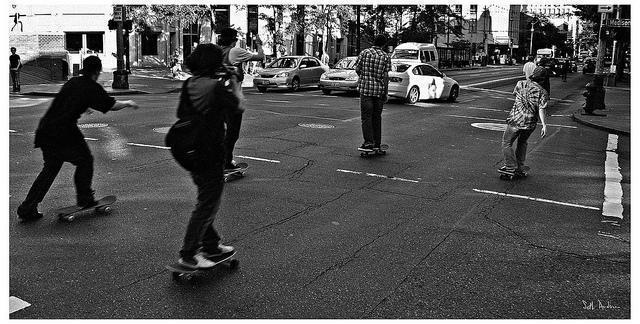What type of shirt is the man on the right wearing?
Indicate the correct response by choosing from the four available options to answer the question.
Options: Plaid, tie dye, flannel, hippie special. Tie dye. 